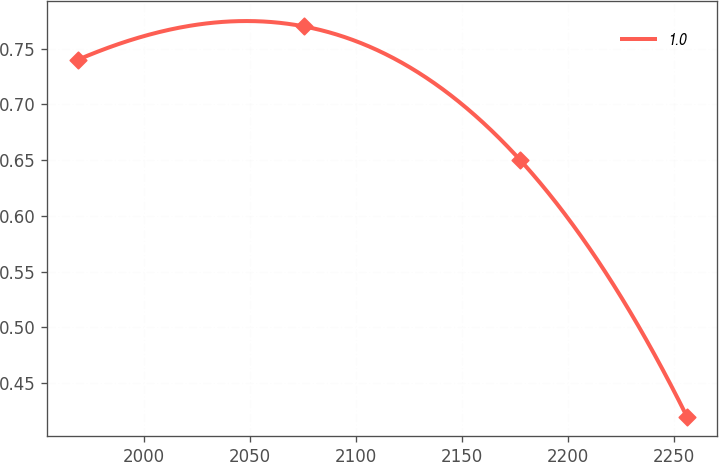Convert chart to OTSL. <chart><loc_0><loc_0><loc_500><loc_500><line_chart><ecel><fcel>1.0<nl><fcel>1968.62<fcel>0.74<nl><fcel>2075.3<fcel>0.77<nl><fcel>2177.59<fcel>0.65<nl><fcel>2256.29<fcel>0.42<nl></chart> 